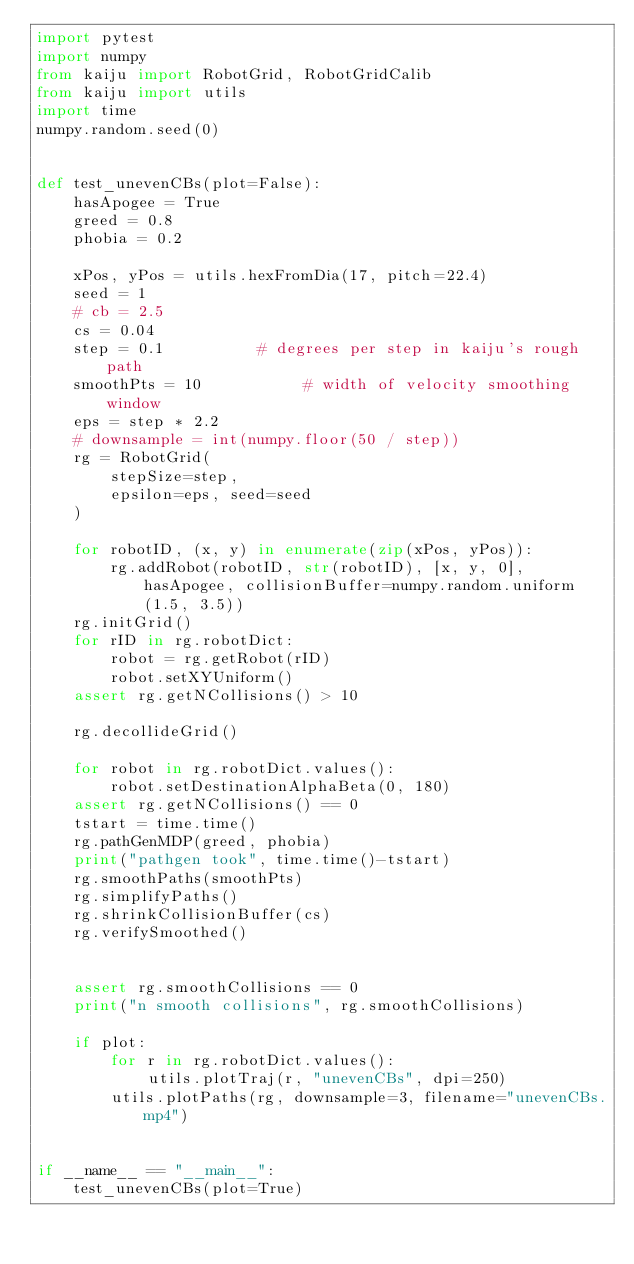Convert code to text. <code><loc_0><loc_0><loc_500><loc_500><_Python_>import pytest
import numpy
from kaiju import RobotGrid, RobotGridCalib
from kaiju import utils
import time
numpy.random.seed(0)


def test_unevenCBs(plot=False):
    hasApogee = True
    greed = 0.8
    phobia = 0.2

    xPos, yPos = utils.hexFromDia(17, pitch=22.4)
    seed = 1
    # cb = 2.5
    cs = 0.04
    step = 0.1          # degrees per step in kaiju's rough path
    smoothPts = 10           # width of velocity smoothing window
    eps = step * 2.2
    # downsample = int(numpy.floor(50 / step))
    rg = RobotGrid(
        stepSize=step,
        epsilon=eps, seed=seed
    )

    for robotID, (x, y) in enumerate(zip(xPos, yPos)):
        rg.addRobot(robotID, str(robotID), [x, y, 0], hasApogee, collisionBuffer=numpy.random.uniform(1.5, 3.5))
    rg.initGrid()
    for rID in rg.robotDict:
        robot = rg.getRobot(rID)
        robot.setXYUniform()
    assert rg.getNCollisions() > 10

    rg.decollideGrid()

    for robot in rg.robotDict.values():
        robot.setDestinationAlphaBeta(0, 180)
    assert rg.getNCollisions() == 0
    tstart = time.time()
    rg.pathGenMDP(greed, phobia)
    print("pathgen took", time.time()-tstart)
    rg.smoothPaths(smoothPts)
    rg.simplifyPaths()
    rg.shrinkCollisionBuffer(cs)
    rg.verifySmoothed()


    assert rg.smoothCollisions == 0
    print("n smooth collisions", rg.smoothCollisions)

    if plot:
        for r in rg.robotDict.values():
            utils.plotTraj(r, "unevenCBs", dpi=250)
        utils.plotPaths(rg, downsample=3, filename="unevenCBs.mp4")


if __name__ == "__main__":
    test_unevenCBs(plot=True)
</code> 